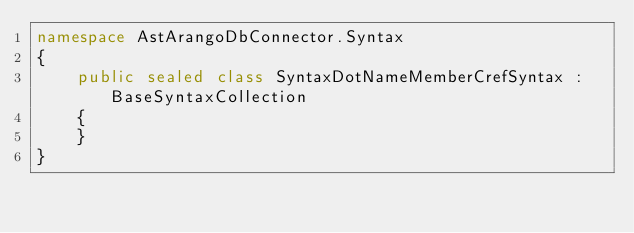Convert code to text. <code><loc_0><loc_0><loc_500><loc_500><_C#_>namespace AstArangoDbConnector.Syntax
{
    public sealed class SyntaxDotNameMemberCrefSyntax : BaseSyntaxCollection
    {
    }
}</code> 